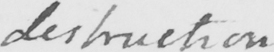What text is written in this handwritten line? destruction 